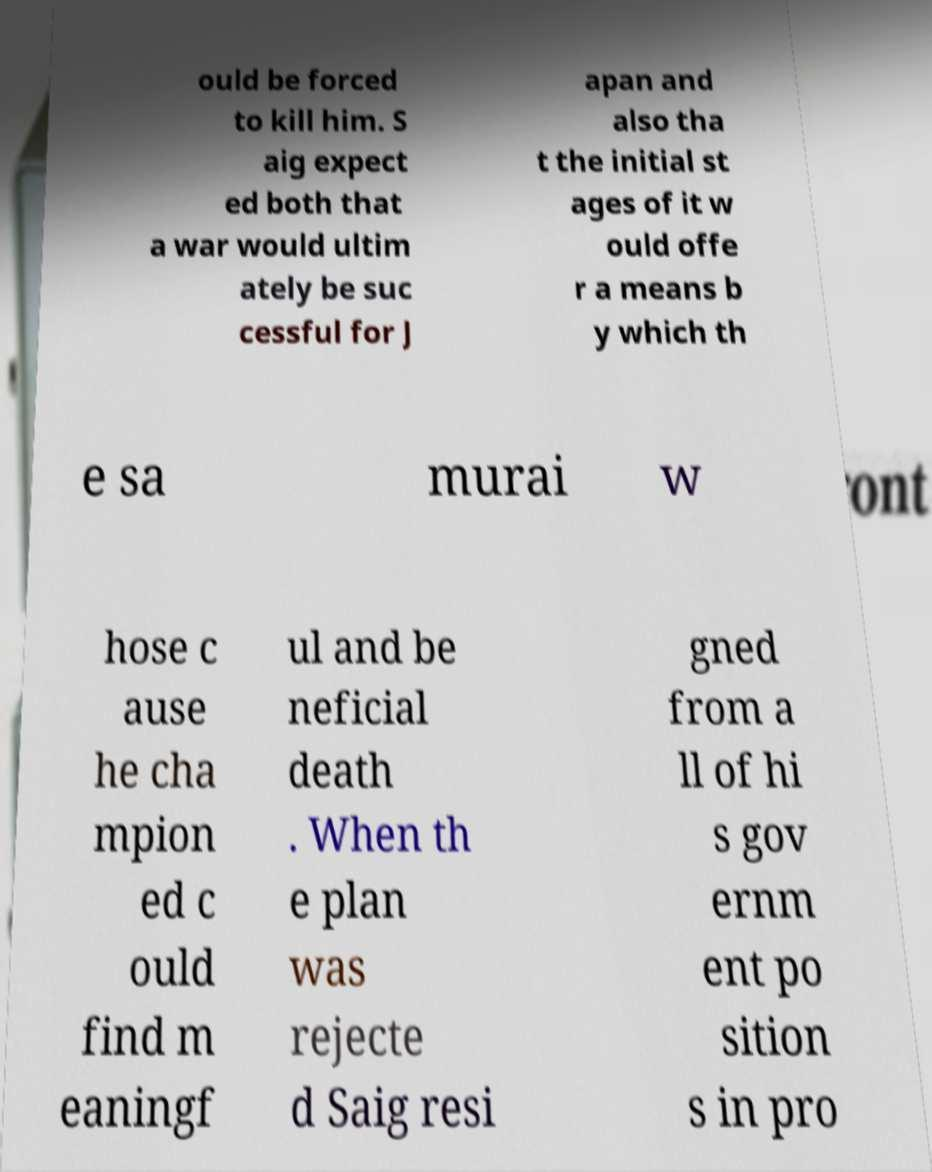Could you assist in decoding the text presented in this image and type it out clearly? ould be forced to kill him. S aig expect ed both that a war would ultim ately be suc cessful for J apan and also tha t the initial st ages of it w ould offe r a means b y which th e sa murai w hose c ause he cha mpion ed c ould find m eaningf ul and be neficial death . When th e plan was rejecte d Saig resi gned from a ll of hi s gov ernm ent po sition s in pro 